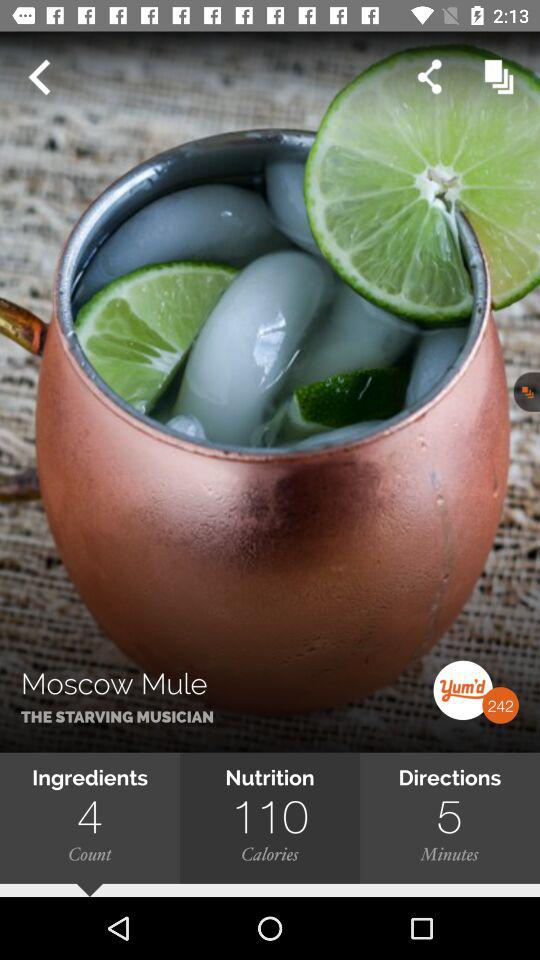What's the duration mentioned in the "Directions"? The duration mentioned in the "Directions" is 5 minutes. 